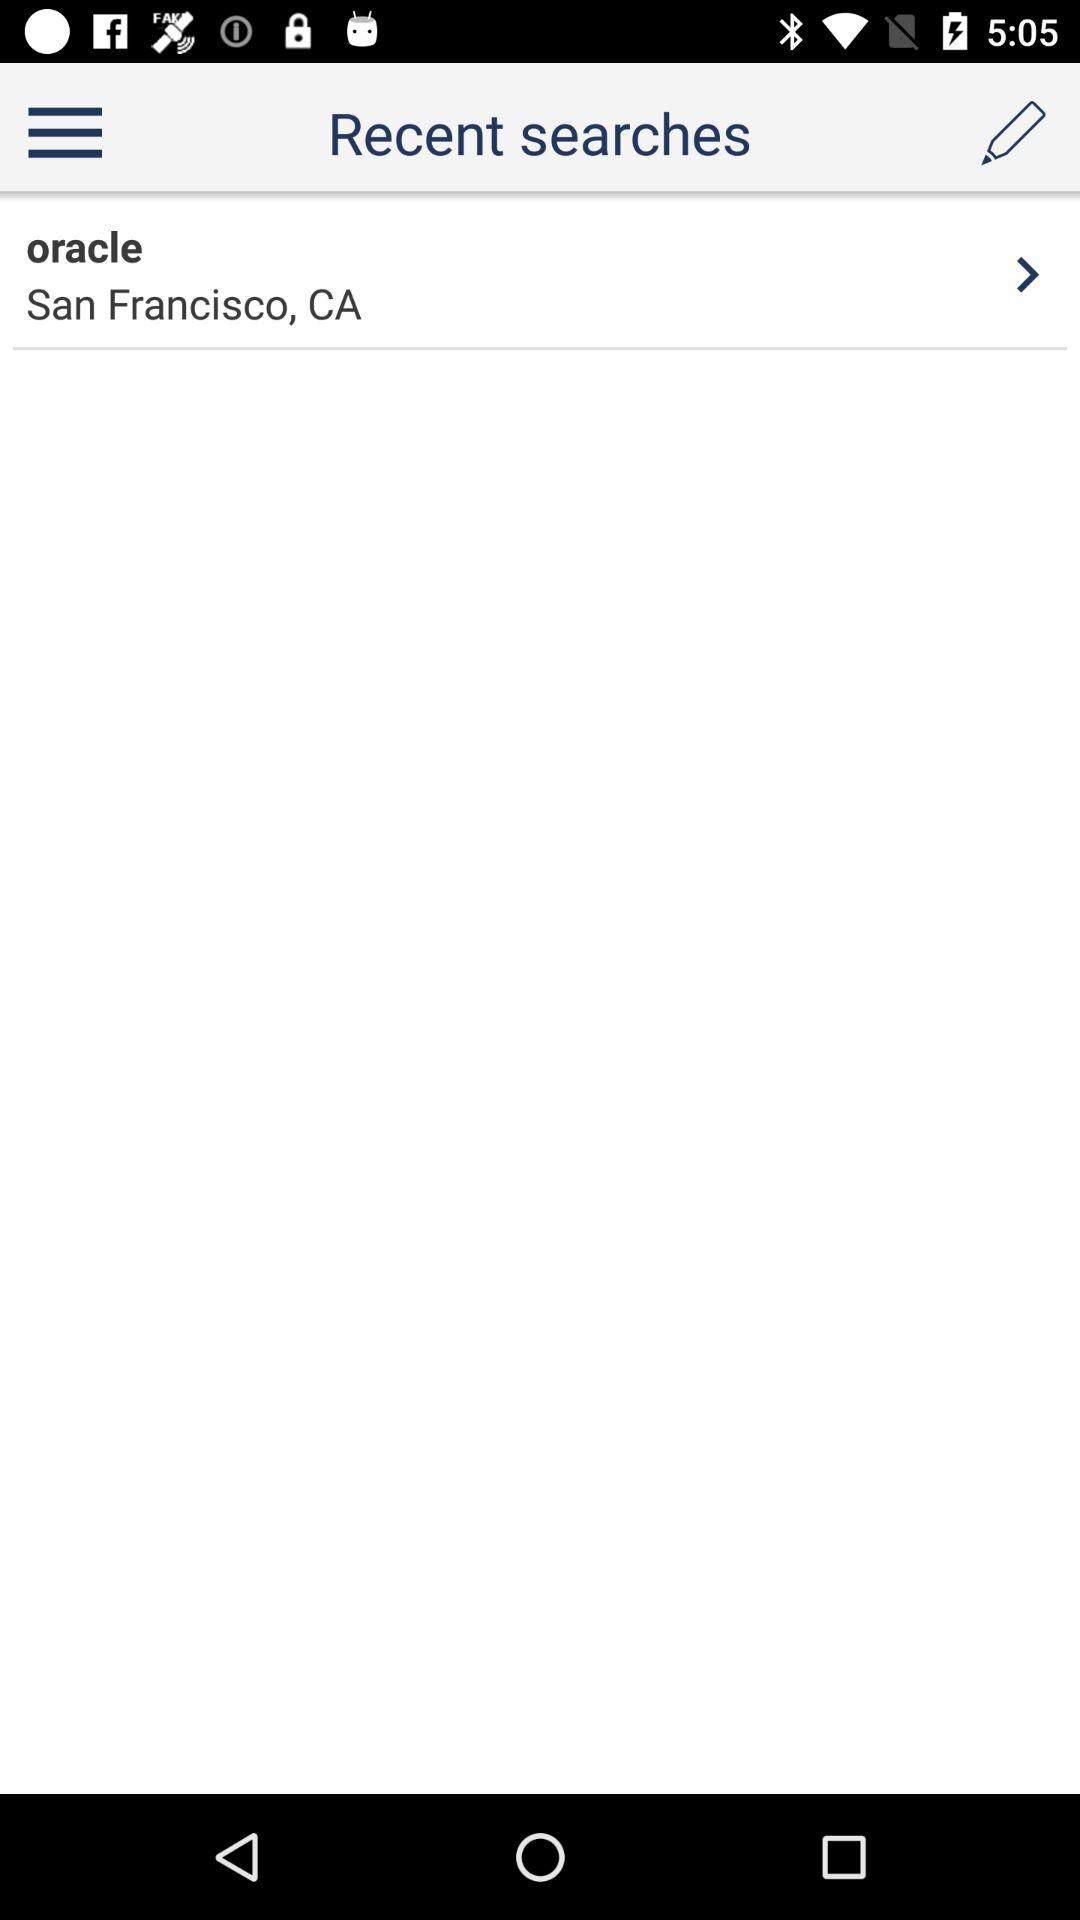What is the mentioned location? The mentioned location is San Francisco, CA. 